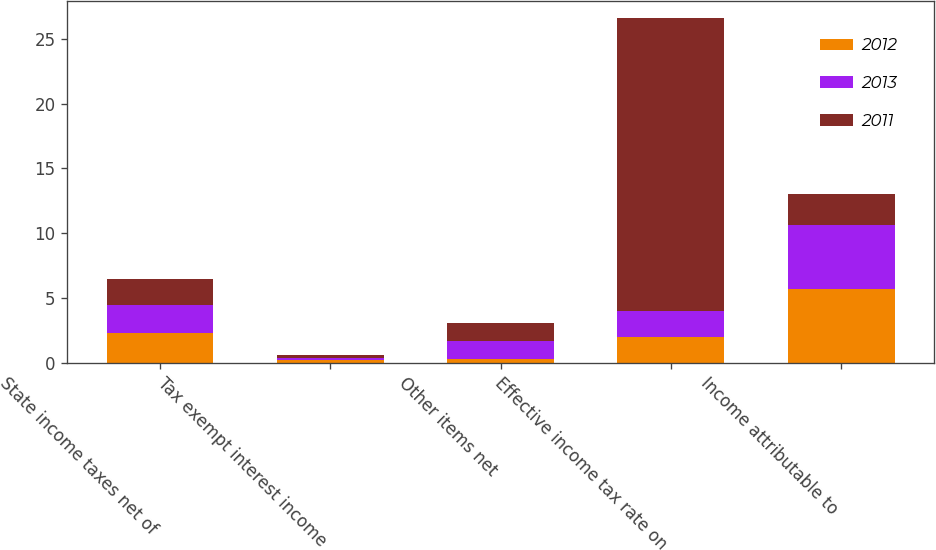<chart> <loc_0><loc_0><loc_500><loc_500><stacked_bar_chart><ecel><fcel>State income taxes net of<fcel>Tax exempt interest income<fcel>Other items net<fcel>Effective income tax rate on<fcel>Income attributable to<nl><fcel>2012<fcel>2.3<fcel>0.2<fcel>0.3<fcel>2<fcel>5.7<nl><fcel>2013<fcel>2.2<fcel>0.2<fcel>1.4<fcel>2<fcel>4.9<nl><fcel>2011<fcel>2<fcel>0.2<fcel>1.4<fcel>22.6<fcel>2.4<nl></chart> 